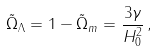Convert formula to latex. <formula><loc_0><loc_0><loc_500><loc_500>\tilde { \Omega } _ { \Lambda } = 1 - \tilde { \Omega } _ { m } = \frac { 3 \gamma } { H ^ { 2 } _ { 0 } } \, ,</formula> 